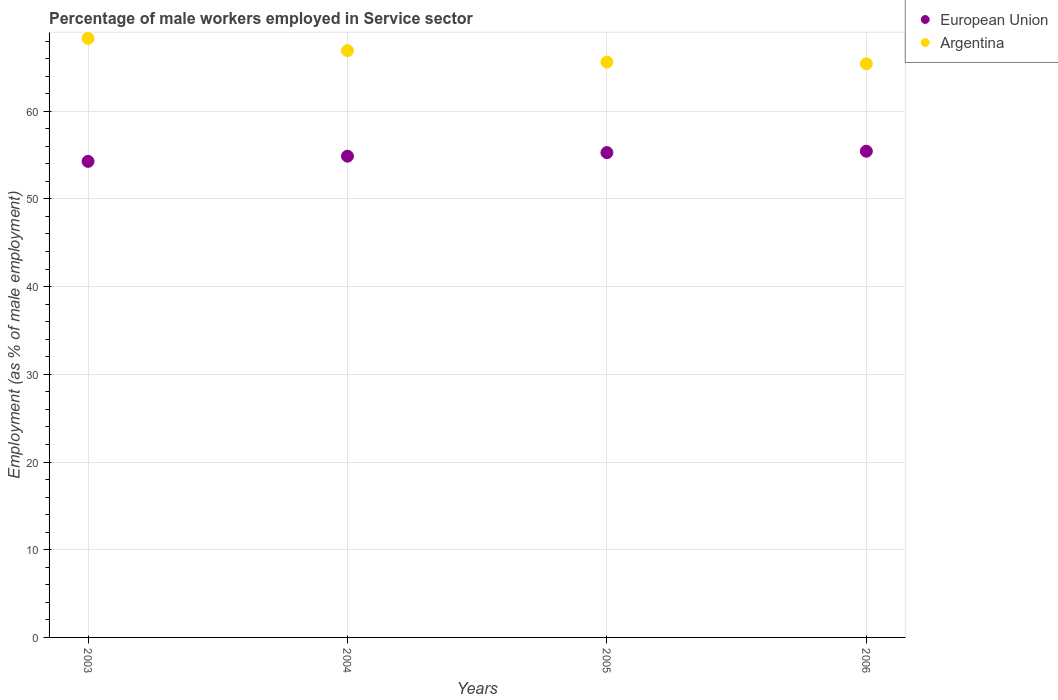How many different coloured dotlines are there?
Make the answer very short. 2. Is the number of dotlines equal to the number of legend labels?
Keep it short and to the point. Yes. What is the percentage of male workers employed in Service sector in Argentina in 2003?
Ensure brevity in your answer.  68.3. Across all years, what is the maximum percentage of male workers employed in Service sector in European Union?
Your response must be concise. 55.44. Across all years, what is the minimum percentage of male workers employed in Service sector in Argentina?
Offer a very short reply. 65.4. In which year was the percentage of male workers employed in Service sector in Argentina maximum?
Your answer should be compact. 2003. What is the total percentage of male workers employed in Service sector in European Union in the graph?
Your answer should be very brief. 219.86. What is the difference between the percentage of male workers employed in Service sector in European Union in 2003 and that in 2004?
Provide a succinct answer. -0.59. What is the difference between the percentage of male workers employed in Service sector in Argentina in 2004 and the percentage of male workers employed in Service sector in European Union in 2003?
Keep it short and to the point. 12.62. What is the average percentage of male workers employed in Service sector in Argentina per year?
Give a very brief answer. 66.55. In the year 2004, what is the difference between the percentage of male workers employed in Service sector in European Union and percentage of male workers employed in Service sector in Argentina?
Your answer should be very brief. -12.03. In how many years, is the percentage of male workers employed in Service sector in European Union greater than 54 %?
Your answer should be very brief. 4. What is the ratio of the percentage of male workers employed in Service sector in European Union in 2003 to that in 2004?
Your answer should be compact. 0.99. Is the percentage of male workers employed in Service sector in Argentina in 2004 less than that in 2005?
Offer a very short reply. No. What is the difference between the highest and the second highest percentage of male workers employed in Service sector in European Union?
Your answer should be compact. 0.16. What is the difference between the highest and the lowest percentage of male workers employed in Service sector in Argentina?
Ensure brevity in your answer.  2.9. Does the percentage of male workers employed in Service sector in European Union monotonically increase over the years?
Keep it short and to the point. Yes. Is the percentage of male workers employed in Service sector in Argentina strictly less than the percentage of male workers employed in Service sector in European Union over the years?
Your answer should be compact. No. How many years are there in the graph?
Ensure brevity in your answer.  4. Are the values on the major ticks of Y-axis written in scientific E-notation?
Keep it short and to the point. No. How many legend labels are there?
Offer a terse response. 2. What is the title of the graph?
Ensure brevity in your answer.  Percentage of male workers employed in Service sector. Does "Benin" appear as one of the legend labels in the graph?
Give a very brief answer. No. What is the label or title of the X-axis?
Make the answer very short. Years. What is the label or title of the Y-axis?
Ensure brevity in your answer.  Employment (as % of male employment). What is the Employment (as % of male employment) in European Union in 2003?
Keep it short and to the point. 54.28. What is the Employment (as % of male employment) in Argentina in 2003?
Your response must be concise. 68.3. What is the Employment (as % of male employment) of European Union in 2004?
Provide a succinct answer. 54.87. What is the Employment (as % of male employment) in Argentina in 2004?
Offer a very short reply. 66.9. What is the Employment (as % of male employment) in European Union in 2005?
Offer a very short reply. 55.28. What is the Employment (as % of male employment) of Argentina in 2005?
Your answer should be compact. 65.6. What is the Employment (as % of male employment) of European Union in 2006?
Make the answer very short. 55.44. What is the Employment (as % of male employment) of Argentina in 2006?
Your answer should be compact. 65.4. Across all years, what is the maximum Employment (as % of male employment) of European Union?
Make the answer very short. 55.44. Across all years, what is the maximum Employment (as % of male employment) of Argentina?
Your answer should be very brief. 68.3. Across all years, what is the minimum Employment (as % of male employment) of European Union?
Provide a short and direct response. 54.28. Across all years, what is the minimum Employment (as % of male employment) in Argentina?
Your answer should be very brief. 65.4. What is the total Employment (as % of male employment) of European Union in the graph?
Offer a very short reply. 219.86. What is the total Employment (as % of male employment) of Argentina in the graph?
Offer a very short reply. 266.2. What is the difference between the Employment (as % of male employment) of European Union in 2003 and that in 2004?
Make the answer very short. -0.59. What is the difference between the Employment (as % of male employment) of European Union in 2003 and that in 2005?
Provide a short and direct response. -1. What is the difference between the Employment (as % of male employment) of Argentina in 2003 and that in 2005?
Your answer should be compact. 2.7. What is the difference between the Employment (as % of male employment) in European Union in 2003 and that in 2006?
Provide a succinct answer. -1.16. What is the difference between the Employment (as % of male employment) in European Union in 2004 and that in 2005?
Your response must be concise. -0.41. What is the difference between the Employment (as % of male employment) in European Union in 2004 and that in 2006?
Your response must be concise. -0.57. What is the difference between the Employment (as % of male employment) in Argentina in 2004 and that in 2006?
Offer a terse response. 1.5. What is the difference between the Employment (as % of male employment) of European Union in 2005 and that in 2006?
Make the answer very short. -0.16. What is the difference between the Employment (as % of male employment) in Argentina in 2005 and that in 2006?
Give a very brief answer. 0.2. What is the difference between the Employment (as % of male employment) in European Union in 2003 and the Employment (as % of male employment) in Argentina in 2004?
Make the answer very short. -12.62. What is the difference between the Employment (as % of male employment) of European Union in 2003 and the Employment (as % of male employment) of Argentina in 2005?
Make the answer very short. -11.32. What is the difference between the Employment (as % of male employment) of European Union in 2003 and the Employment (as % of male employment) of Argentina in 2006?
Give a very brief answer. -11.12. What is the difference between the Employment (as % of male employment) of European Union in 2004 and the Employment (as % of male employment) of Argentina in 2005?
Keep it short and to the point. -10.73. What is the difference between the Employment (as % of male employment) in European Union in 2004 and the Employment (as % of male employment) in Argentina in 2006?
Your response must be concise. -10.53. What is the difference between the Employment (as % of male employment) in European Union in 2005 and the Employment (as % of male employment) in Argentina in 2006?
Offer a terse response. -10.12. What is the average Employment (as % of male employment) of European Union per year?
Your answer should be compact. 54.97. What is the average Employment (as % of male employment) of Argentina per year?
Your answer should be compact. 66.55. In the year 2003, what is the difference between the Employment (as % of male employment) in European Union and Employment (as % of male employment) in Argentina?
Your response must be concise. -14.02. In the year 2004, what is the difference between the Employment (as % of male employment) in European Union and Employment (as % of male employment) in Argentina?
Ensure brevity in your answer.  -12.03. In the year 2005, what is the difference between the Employment (as % of male employment) of European Union and Employment (as % of male employment) of Argentina?
Provide a short and direct response. -10.32. In the year 2006, what is the difference between the Employment (as % of male employment) of European Union and Employment (as % of male employment) of Argentina?
Your response must be concise. -9.96. What is the ratio of the Employment (as % of male employment) in European Union in 2003 to that in 2004?
Your answer should be compact. 0.99. What is the ratio of the Employment (as % of male employment) of Argentina in 2003 to that in 2004?
Offer a very short reply. 1.02. What is the ratio of the Employment (as % of male employment) in European Union in 2003 to that in 2005?
Offer a terse response. 0.98. What is the ratio of the Employment (as % of male employment) in Argentina in 2003 to that in 2005?
Your answer should be very brief. 1.04. What is the ratio of the Employment (as % of male employment) in European Union in 2003 to that in 2006?
Your answer should be very brief. 0.98. What is the ratio of the Employment (as % of male employment) in Argentina in 2003 to that in 2006?
Give a very brief answer. 1.04. What is the ratio of the Employment (as % of male employment) of Argentina in 2004 to that in 2005?
Your answer should be very brief. 1.02. What is the ratio of the Employment (as % of male employment) in Argentina in 2004 to that in 2006?
Provide a succinct answer. 1.02. What is the difference between the highest and the second highest Employment (as % of male employment) of European Union?
Make the answer very short. 0.16. What is the difference between the highest and the lowest Employment (as % of male employment) in European Union?
Your answer should be very brief. 1.16. 